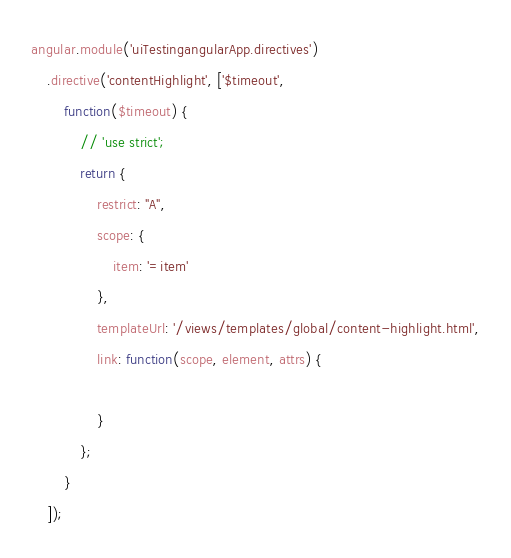<code> <loc_0><loc_0><loc_500><loc_500><_JavaScript_>angular.module('uiTestingangularApp.directives')
    .directive('contentHighlight', ['$timeout',
        function($timeout) {
            // 'use strict';
            return {
                restrict: "A",
                scope: {
                    item: '=item'
                },
                templateUrl: '/views/templates/global/content-highlight.html',
                link: function(scope, element, attrs) {
                    
                }
            };
        }
    ]);</code> 